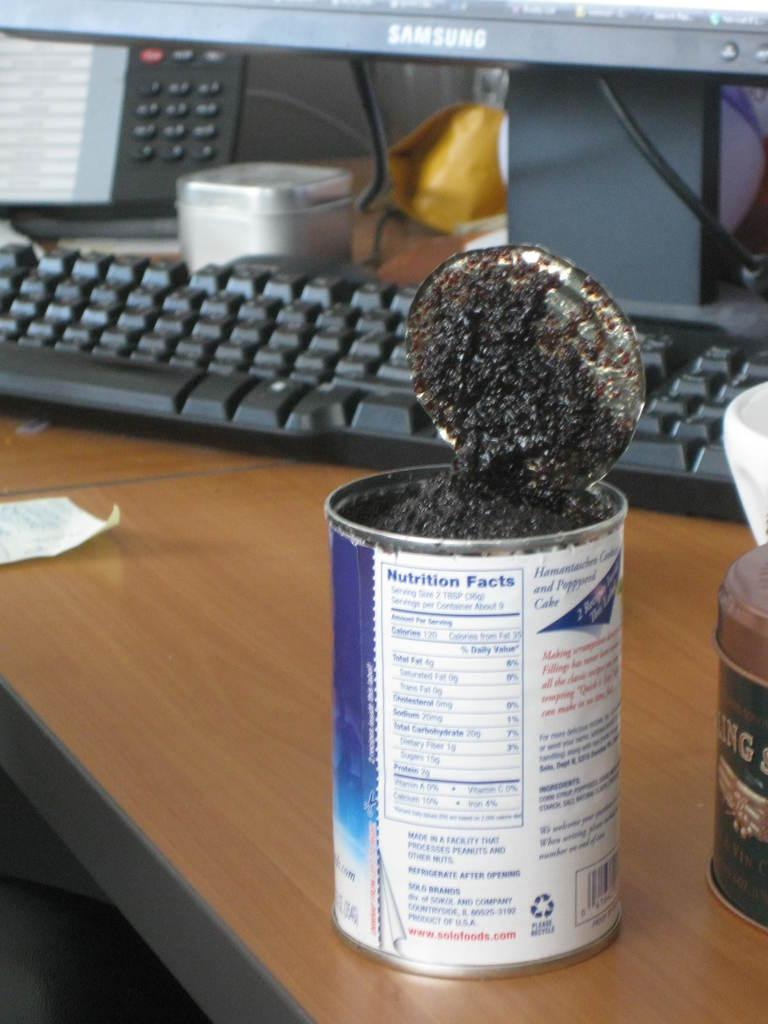What is the main object in the image? There is a keyboard in the image. What else can be seen on the table in the image? There is a box, tins, paper, a system, and other objects on the table in the image. Can you describe the box in the image? The box is one of the objects on the table, but its specific characteristics are not mentioned in the facts. What type of system is present in the image? The facts mention that there is a system in the image, but its specific type or function is not described. How do the pets contribute to the income in the image? There are no pets mentioned in the image, so it is not possible to determine their contribution to any income. 